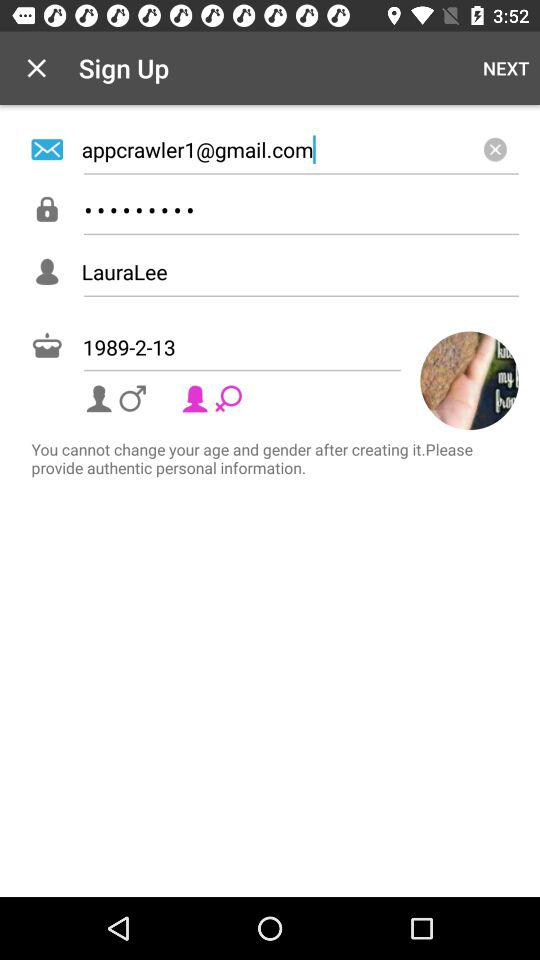What is the date of birth? The date of birth is 1989-2-13. 